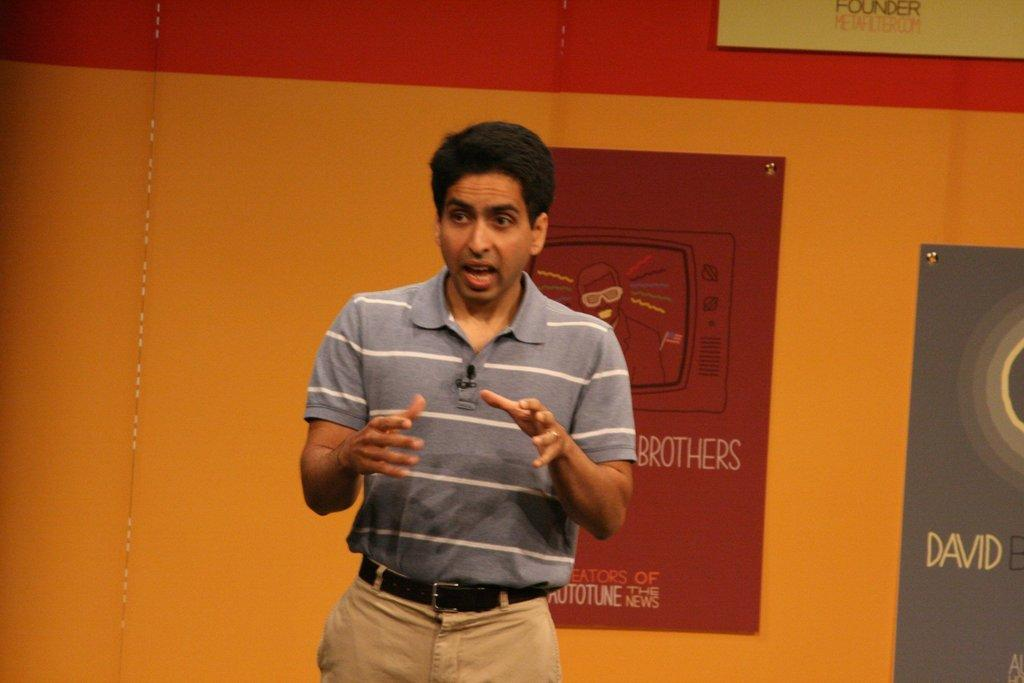What is the man in the image doing? The man is standing on stage and speaking. What can be seen behind the man? There is a wall behind the man. Are there any decorations or items on the wall? Yes, the wall has posters on it. What type of chain can be seen hanging from the man's neck in the image? There is no chain visible around the man's neck in the image. What are the man's hobbies, as depicted in the image? The image does not provide information about the man's hobbies. 